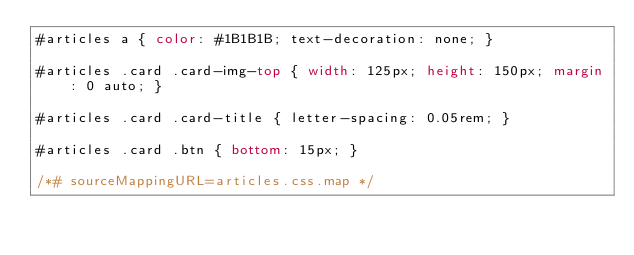<code> <loc_0><loc_0><loc_500><loc_500><_CSS_>#articles a { color: #1B1B1B; text-decoration: none; }

#articles .card .card-img-top { width: 125px; height: 150px; margin: 0 auto; }

#articles .card .card-title { letter-spacing: 0.05rem; }

#articles .card .btn { bottom: 15px; }

/*# sourceMappingURL=articles.css.map */</code> 